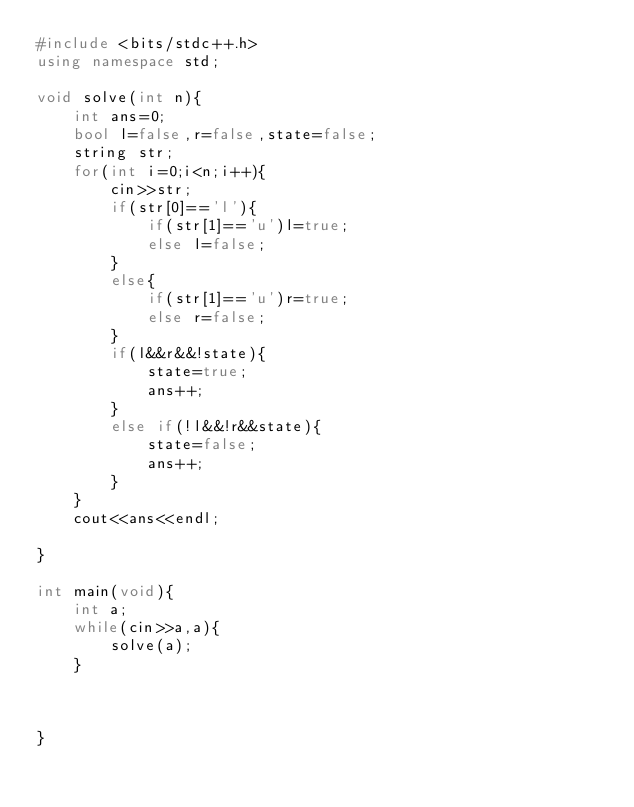Convert code to text. <code><loc_0><loc_0><loc_500><loc_500><_C++_>#include <bits/stdc++.h>
using namespace std;

void solve(int n){
    int ans=0;
    bool l=false,r=false,state=false;
    string str;
    for(int i=0;i<n;i++){
        cin>>str;
        if(str[0]=='l'){
            if(str[1]=='u')l=true;
            else l=false;
        }
        else{
            if(str[1]=='u')r=true;
            else r=false;
        }
        if(l&&r&&!state){
            state=true;
            ans++;
        }
        else if(!l&&!r&&state){
            state=false;
            ans++;
        }
    }
    cout<<ans<<endl;
    
}

int main(void){
    int a;
    while(cin>>a,a){
        solve(a);
    }
    
    
    
}</code> 